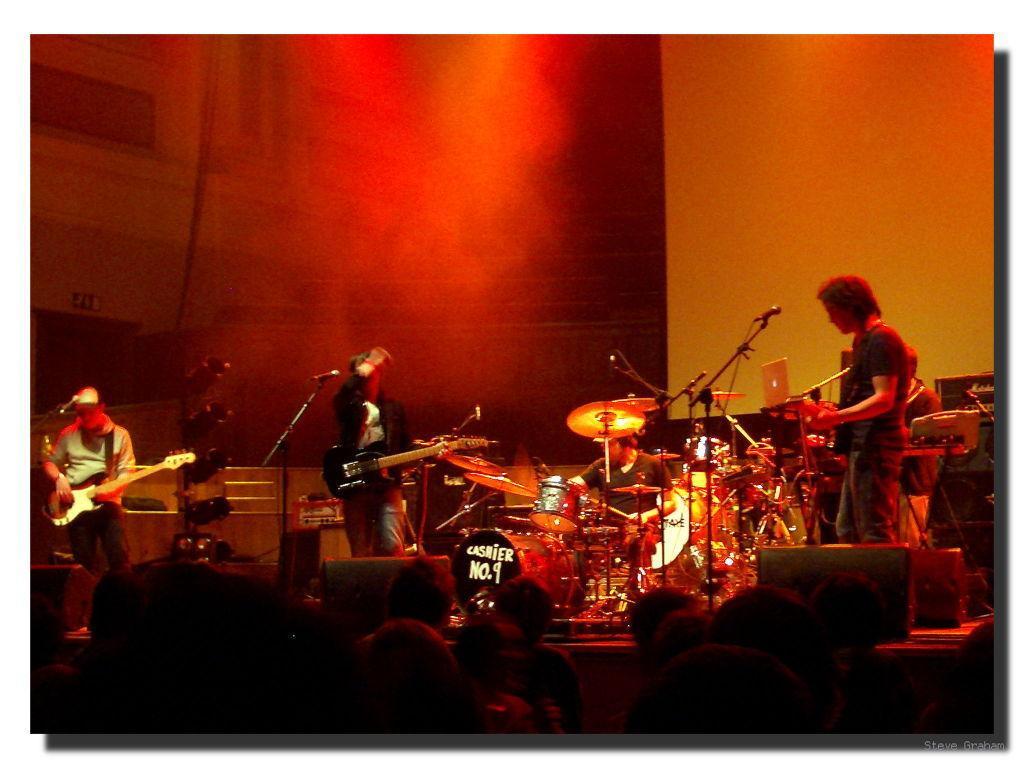How would you summarize this image in a sentence or two? In this picture we can see three persons standing on the floor and playing guitars. Here we can see a man who is playing drums. These are the mikes. And there are some musical instruments. On the background there is a wall. 